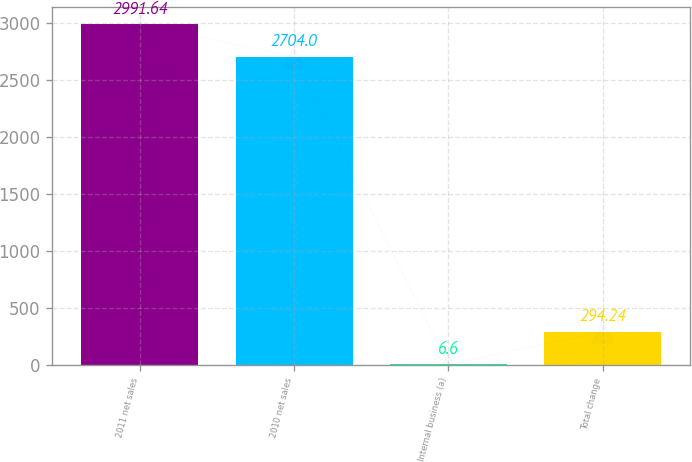Convert chart. <chart><loc_0><loc_0><loc_500><loc_500><bar_chart><fcel>2011 net sales<fcel>2010 net sales<fcel>Internal business (a)<fcel>Total change<nl><fcel>2991.64<fcel>2704<fcel>6.6<fcel>294.24<nl></chart> 